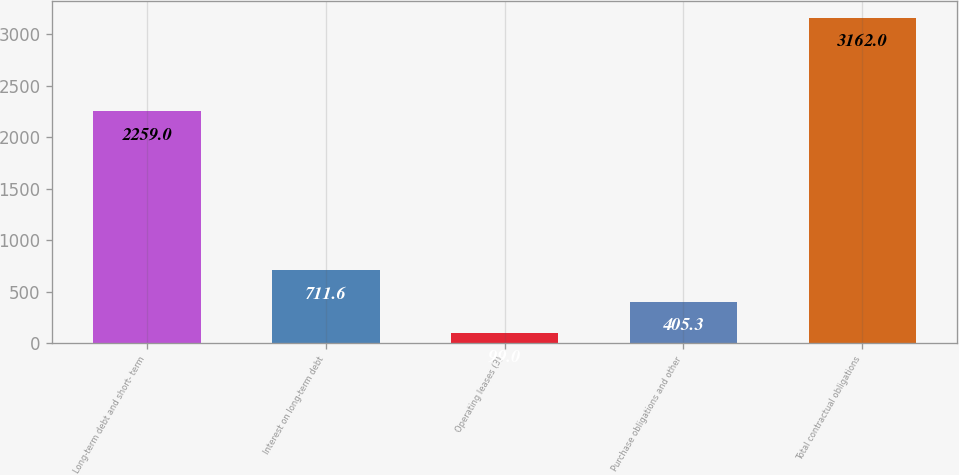<chart> <loc_0><loc_0><loc_500><loc_500><bar_chart><fcel>Long-term debt and short- term<fcel>Interest on long-term debt<fcel>Operating leases (3)<fcel>Purchase obligations and other<fcel>Total contractual obligations<nl><fcel>2259<fcel>711.6<fcel>99<fcel>405.3<fcel>3162<nl></chart> 